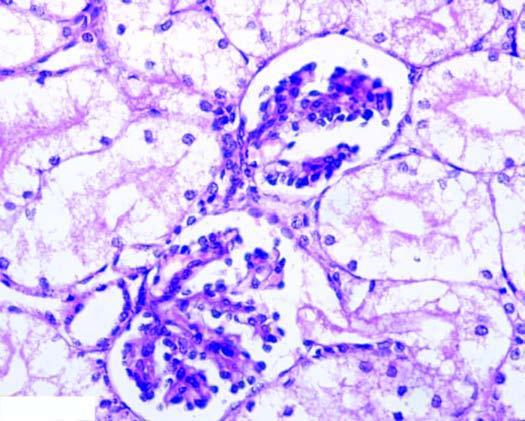re two daughter cells distended with cytoplasmic vacuoles while the interstitial vasculature is compressed?
Answer the question using a single word or phrase. No 